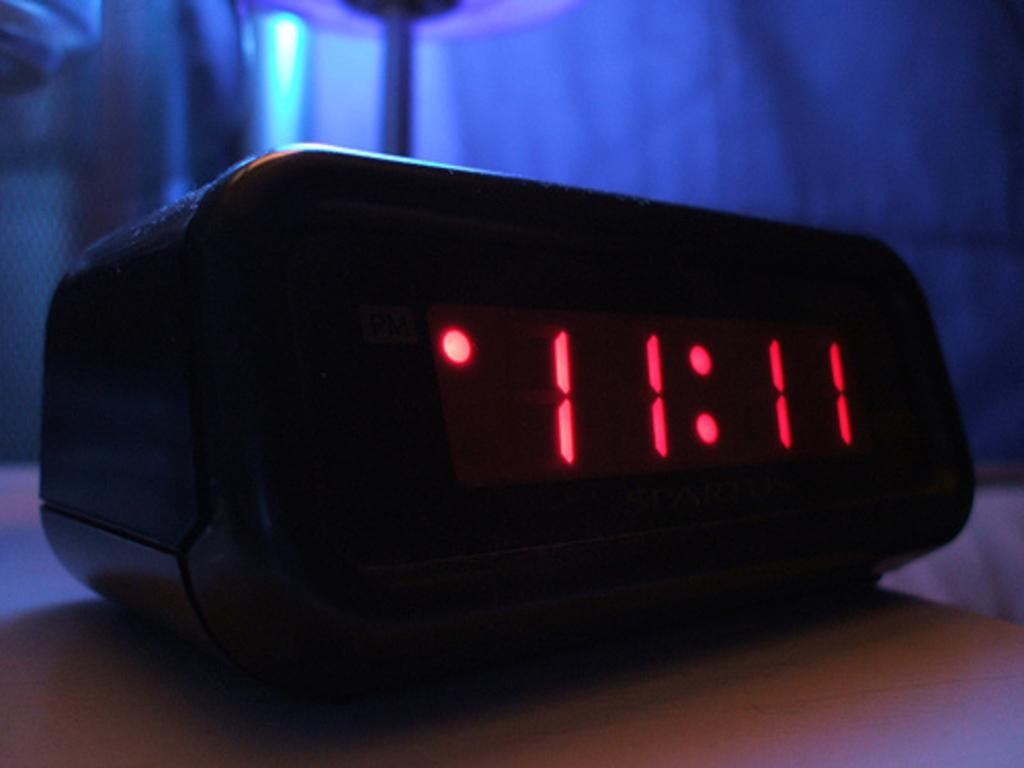<image>
Describe the image concisely. an alarm clock sitting on a wooden table showing the time of 11:11 